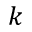<formula> <loc_0><loc_0><loc_500><loc_500>k</formula> 